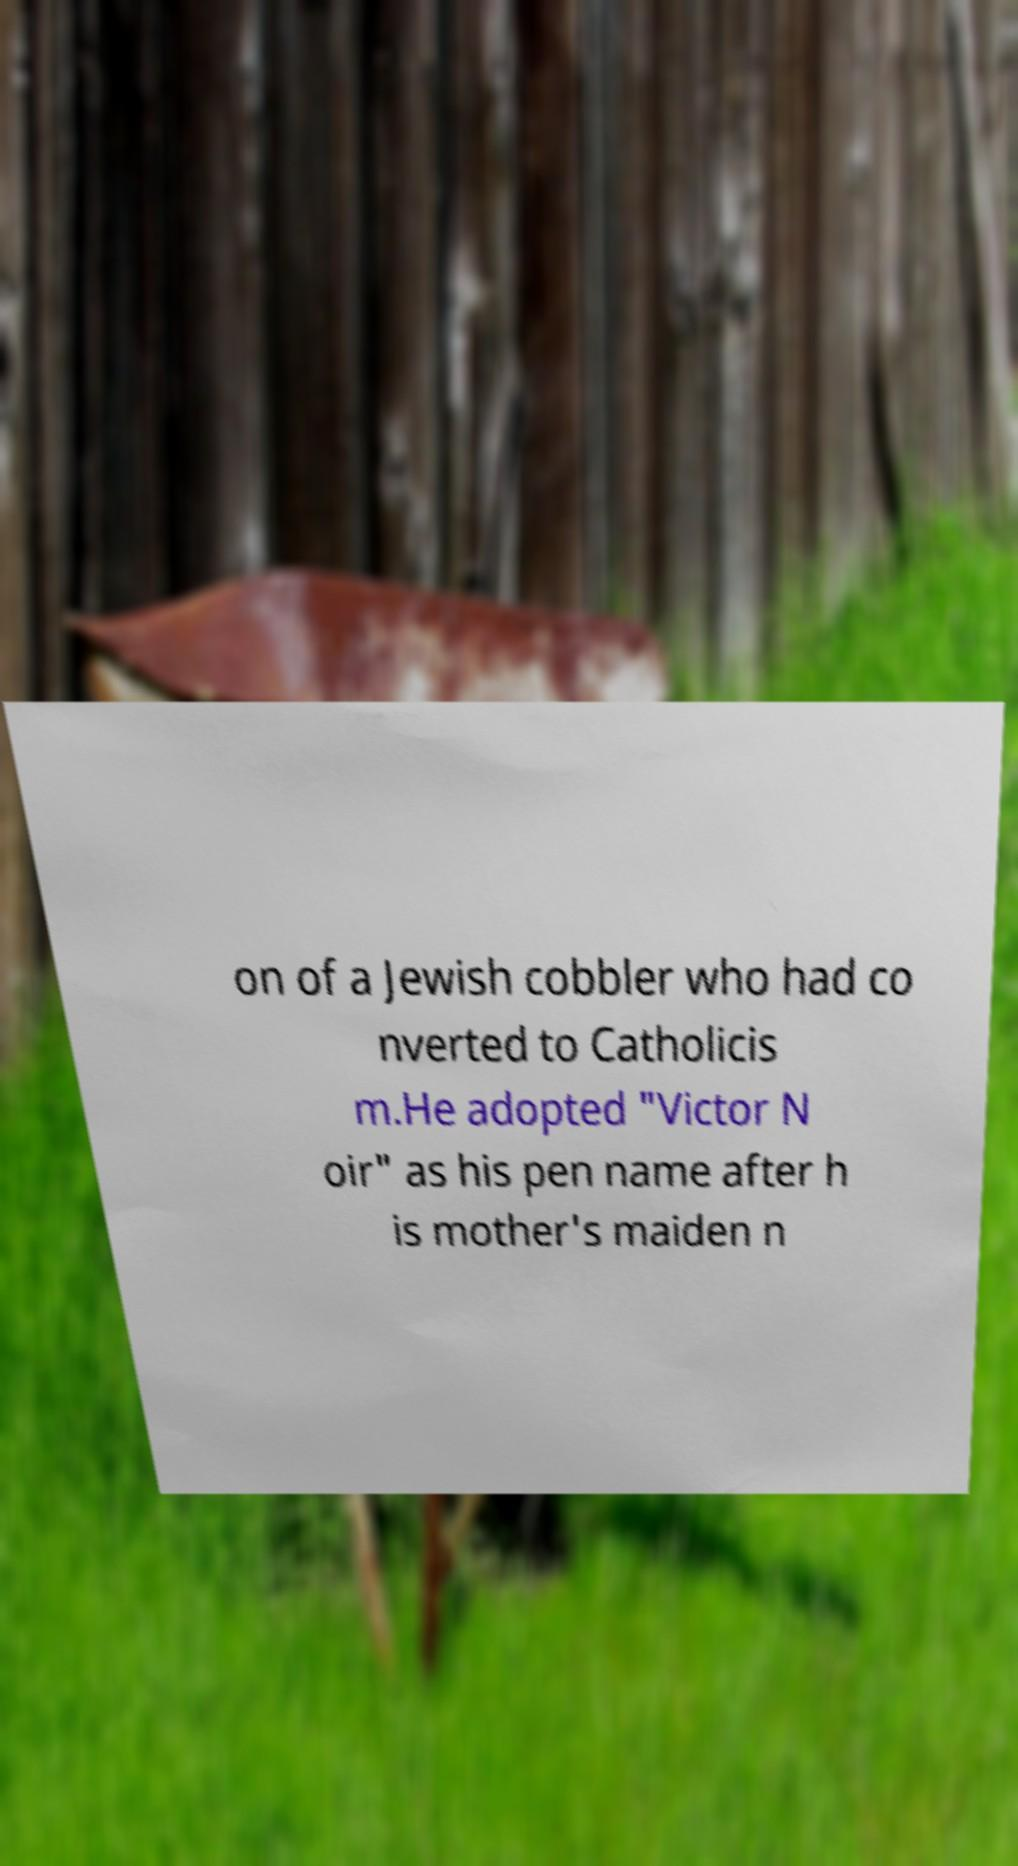Can you accurately transcribe the text from the provided image for me? on of a Jewish cobbler who had co nverted to Catholicis m.He adopted "Victor N oir" as his pen name after h is mother's maiden n 